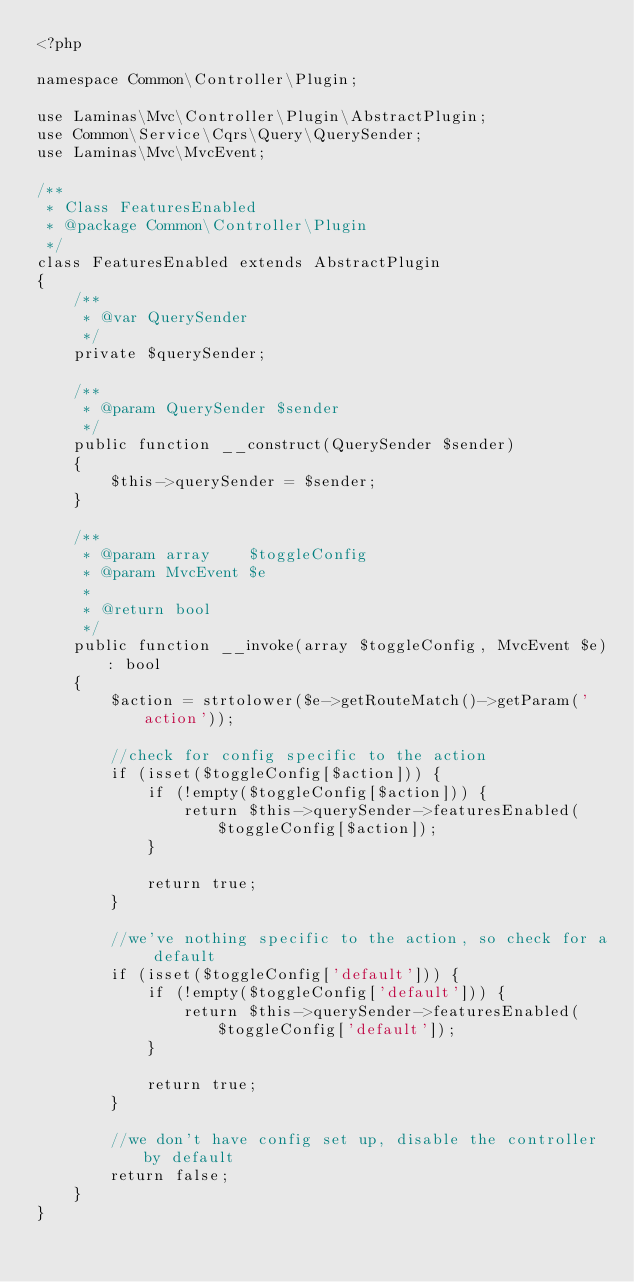<code> <loc_0><loc_0><loc_500><loc_500><_PHP_><?php

namespace Common\Controller\Plugin;

use Laminas\Mvc\Controller\Plugin\AbstractPlugin;
use Common\Service\Cqrs\Query\QuerySender;
use Laminas\Mvc\MvcEvent;

/**
 * Class FeaturesEnabled
 * @package Common\Controller\Plugin
 */
class FeaturesEnabled extends AbstractPlugin
{
    /**
     * @var QuerySender
     */
    private $querySender;

    /**
     * @param QuerySender $sender
     */
    public function __construct(QuerySender $sender)
    {
        $this->querySender = $sender;
    }

    /**
     * @param array    $toggleConfig
     * @param MvcEvent $e
     *
     * @return bool
     */
    public function __invoke(array $toggleConfig, MvcEvent $e): bool
    {
        $action = strtolower($e->getRouteMatch()->getParam('action'));

        //check for config specific to the action
        if (isset($toggleConfig[$action])) {
            if (!empty($toggleConfig[$action])) {
                return $this->querySender->featuresEnabled($toggleConfig[$action]);
            }

            return true;
        }

        //we've nothing specific to the action, so check for a default
        if (isset($toggleConfig['default'])) {
            if (!empty($toggleConfig['default'])) {
                return $this->querySender->featuresEnabled($toggleConfig['default']);
            }

            return true;
        }

        //we don't have config set up, disable the controller by default
        return false;
    }
}
</code> 